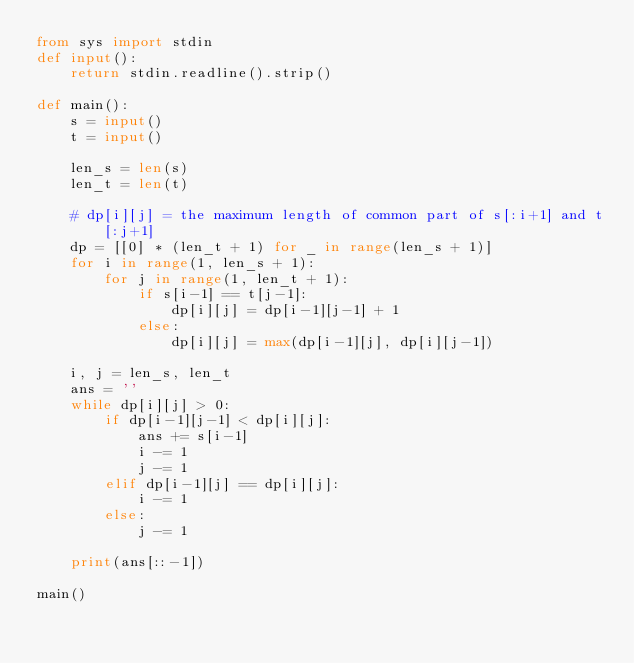<code> <loc_0><loc_0><loc_500><loc_500><_Python_>from sys import stdin
def input():
    return stdin.readline().strip()

def main():
    s = input()
    t = input()

    len_s = len(s)
    len_t = len(t)

    # dp[i][j] = the maximum length of common part of s[:i+1] and t[:j+1]
    dp = [[0] * (len_t + 1) for _ in range(len_s + 1)]
    for i in range(1, len_s + 1):
        for j in range(1, len_t + 1):
            if s[i-1] == t[j-1]:
                dp[i][j] = dp[i-1][j-1] + 1
            else:
                dp[i][j] = max(dp[i-1][j], dp[i][j-1])

    i, j = len_s, len_t
    ans = ''
    while dp[i][j] > 0:
        if dp[i-1][j-1] < dp[i][j]:
            ans += s[i-1]
            i -= 1
            j -= 1
        elif dp[i-1][j] == dp[i][j]:
            i -= 1
        else:
            j -= 1

    print(ans[::-1])

main()
</code> 